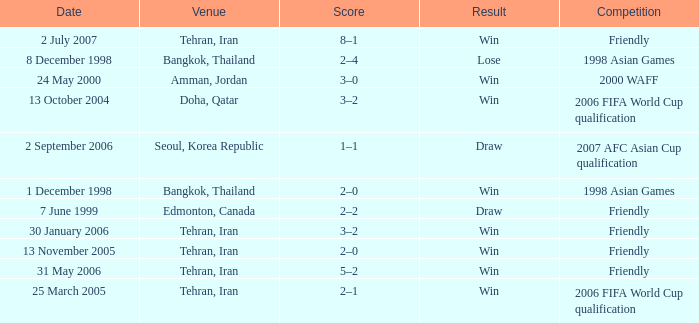Where was the friendly competition on 7 June 1999 played? Edmonton, Canada. 